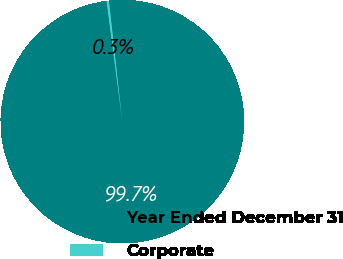<chart> <loc_0><loc_0><loc_500><loc_500><pie_chart><fcel>Year Ended December 31<fcel>Corporate<nl><fcel>99.7%<fcel>0.3%<nl></chart> 